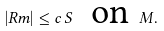Convert formula to latex. <formula><loc_0><loc_0><loc_500><loc_500>\left | R m \right | \leq c \, S \text { \ on } M .</formula> 